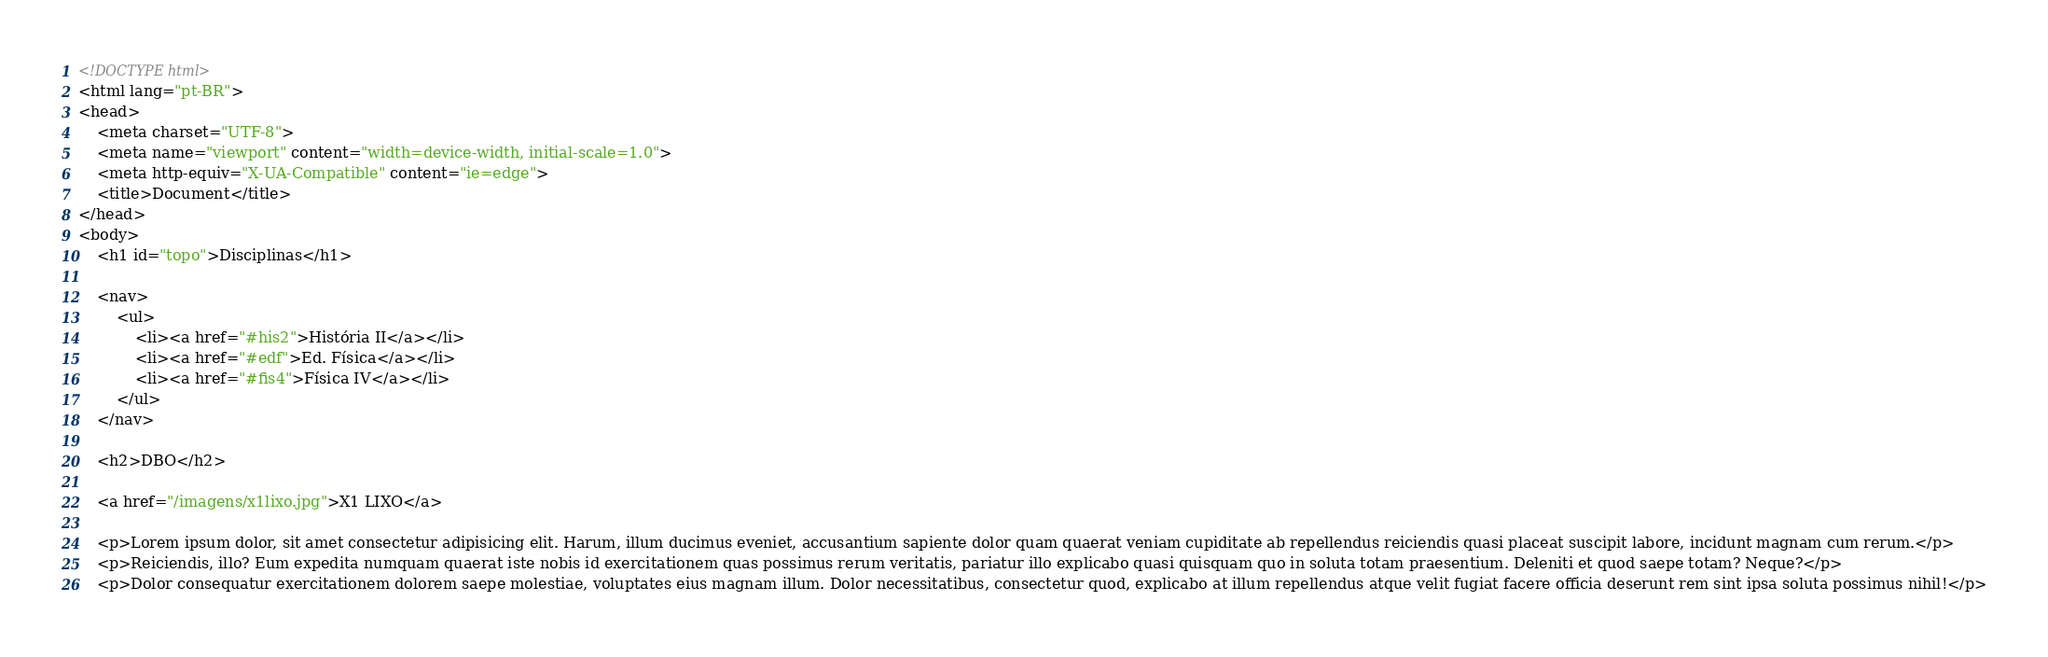<code> <loc_0><loc_0><loc_500><loc_500><_HTML_><!DOCTYPE html>
<html lang="pt-BR">
<head>
    <meta charset="UTF-8">
    <meta name="viewport" content="width=device-width, initial-scale=1.0">
    <meta http-equiv="X-UA-Compatible" content="ie=edge">
    <title>Document</title>
</head>
<body>
    <h1 id="topo">Disciplinas</h1>

    <nav>
        <ul>
            <li><a href="#his2">História II</a></li>
            <li><a href="#edf">Ed. Física</a></li>
            <li><a href="#fis4">Física IV</a></li>
        </ul>
    </nav>

    <h2>DBO</h2>

    <a href="/imagens/x1lixo.jpg">X1 LIXO</a>

    <p>Lorem ipsum dolor, sit amet consectetur adipisicing elit. Harum, illum ducimus eveniet, accusantium sapiente dolor quam quaerat veniam cupiditate ab repellendus reiciendis quasi placeat suscipit labore, incidunt magnam cum rerum.</p>
    <p>Reiciendis, illo? Eum expedita numquam quaerat iste nobis id exercitationem quas possimus rerum veritatis, pariatur illo explicabo quasi quisquam quo in soluta totam praesentium. Deleniti et quod saepe totam? Neque?</p>
    <p>Dolor consequatur exercitationem dolorem saepe molestiae, voluptates eius magnam illum. Dolor necessitatibus, consectetur quod, explicabo at illum repellendus atque velit fugiat facere officia deserunt rem sint ipsa soluta possimus nihil!</p>
</code> 